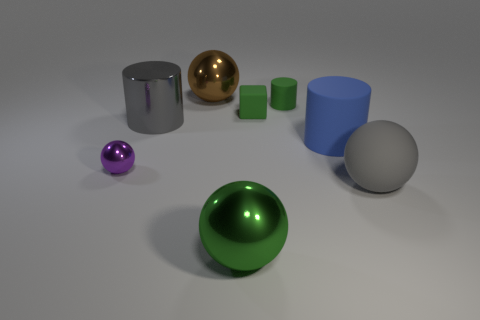The other tiny object that is the same shape as the gray metal thing is what color?
Your response must be concise. Green. Is there any other thing that is the same shape as the big brown metallic thing?
Offer a very short reply. Yes. Are there more blue objects that are behind the gray metallic cylinder than big blue cylinders behind the tiny green rubber block?
Provide a short and direct response. No. How big is the shiny ball that is behind the matte cylinder that is behind the big gray object behind the gray matte sphere?
Provide a succinct answer. Large. Are the large green sphere and the big gray thing in front of the tiny purple sphere made of the same material?
Provide a short and direct response. No. Is the shape of the brown shiny object the same as the tiny purple metal thing?
Provide a succinct answer. Yes. What number of other things are the same material as the tiny purple ball?
Offer a terse response. 3. How many purple metallic objects have the same shape as the big brown object?
Make the answer very short. 1. What is the color of the large thing that is both behind the gray matte thing and right of the large green thing?
Give a very brief answer. Blue. How many big things are there?
Ensure brevity in your answer.  5. 